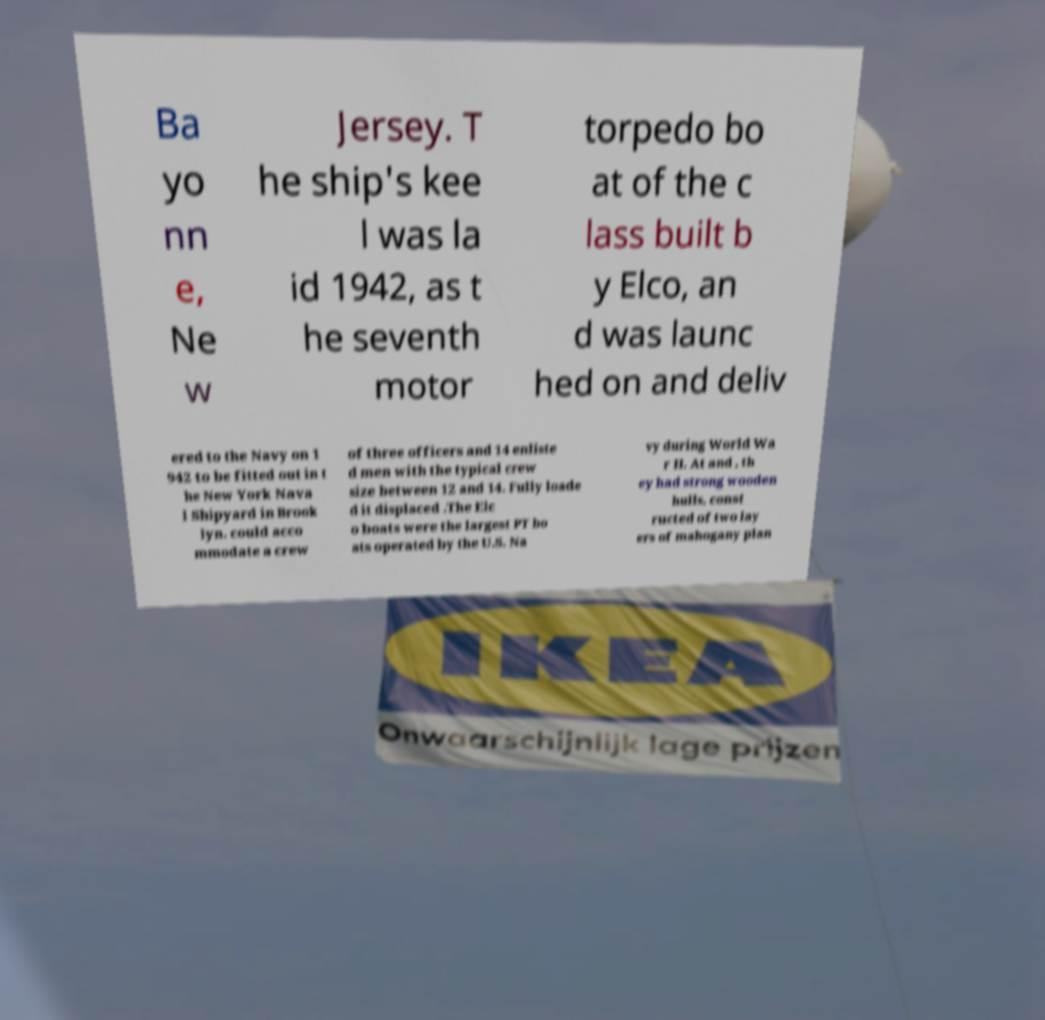Please identify and transcribe the text found in this image. Ba yo nn e, Ne w Jersey. T he ship's kee l was la id 1942, as t he seventh motor torpedo bo at of the c lass built b y Elco, an d was launc hed on and deliv ered to the Navy on 1 942 to be fitted out in t he New York Nava l Shipyard in Brook lyn. could acco mmodate a crew of three officers and 14 enliste d men with the typical crew size between 12 and 14. Fully loade d it displaced .The Elc o boats were the largest PT bo ats operated by the U.S. Na vy during World Wa r II. At and , th ey had strong wooden hulls, const ructed of two lay ers of mahogany plan 